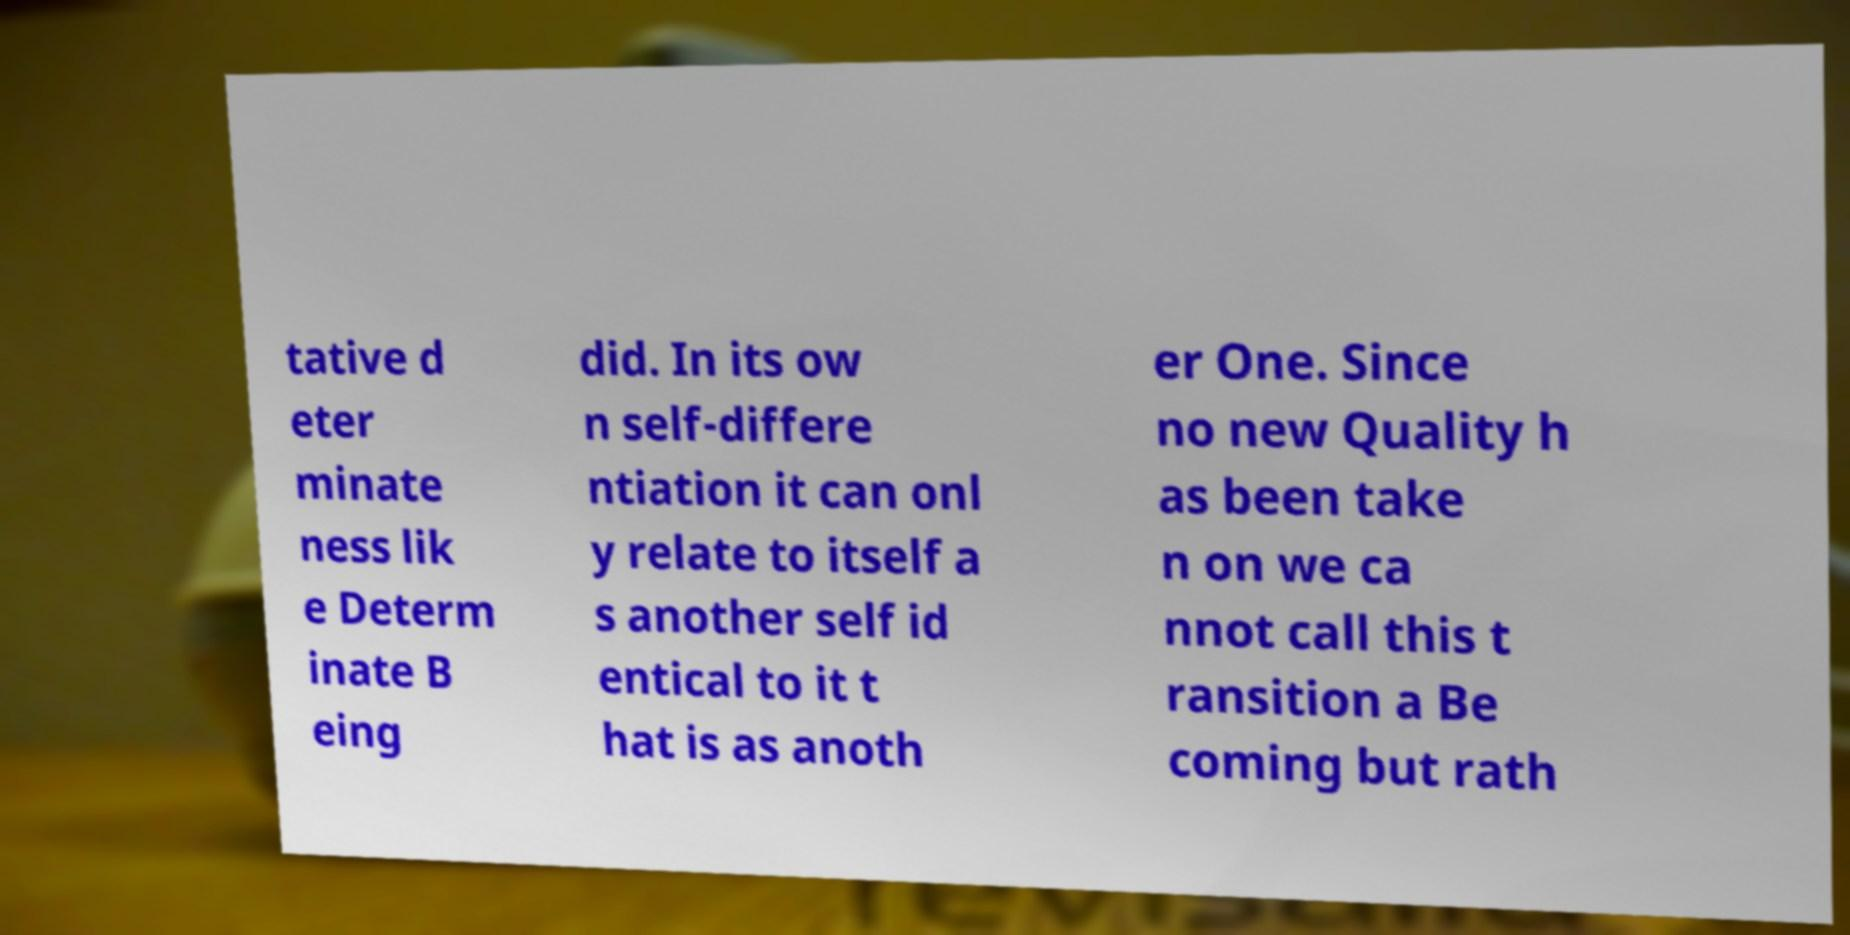Can you accurately transcribe the text from the provided image for me? tative d eter minate ness lik e Determ inate B eing did. In its ow n self-differe ntiation it can onl y relate to itself a s another self id entical to it t hat is as anoth er One. Since no new Quality h as been take n on we ca nnot call this t ransition a Be coming but rath 